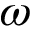Convert formula to latex. <formula><loc_0><loc_0><loc_500><loc_500>\omega</formula> 